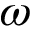Convert formula to latex. <formula><loc_0><loc_0><loc_500><loc_500>\omega</formula> 